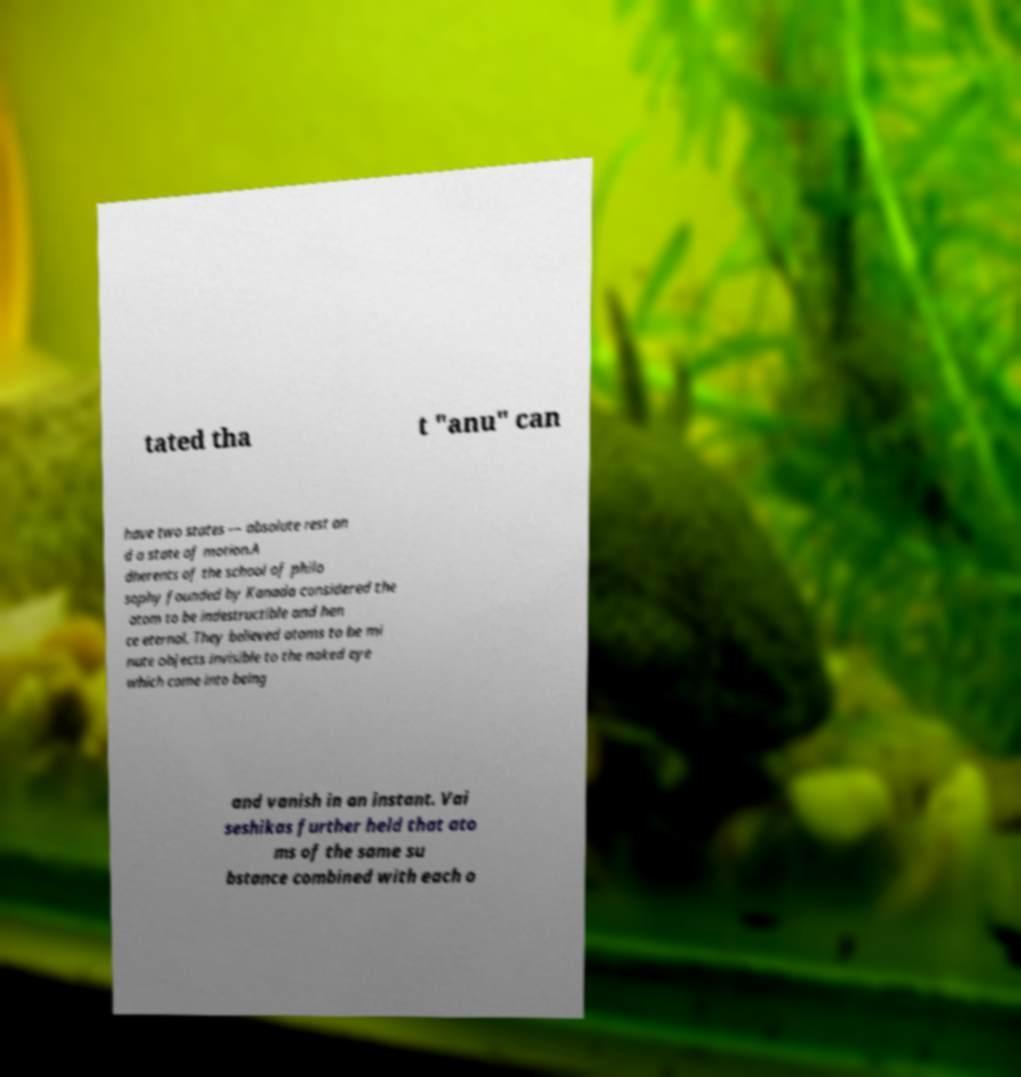Please identify and transcribe the text found in this image. tated tha t "anu" can have two states — absolute rest an d a state of motion.A dherents of the school of philo sophy founded by Kanada considered the atom to be indestructible and hen ce eternal. They believed atoms to be mi nute objects invisible to the naked eye which come into being and vanish in an instant. Vai seshikas further held that ato ms of the same su bstance combined with each o 